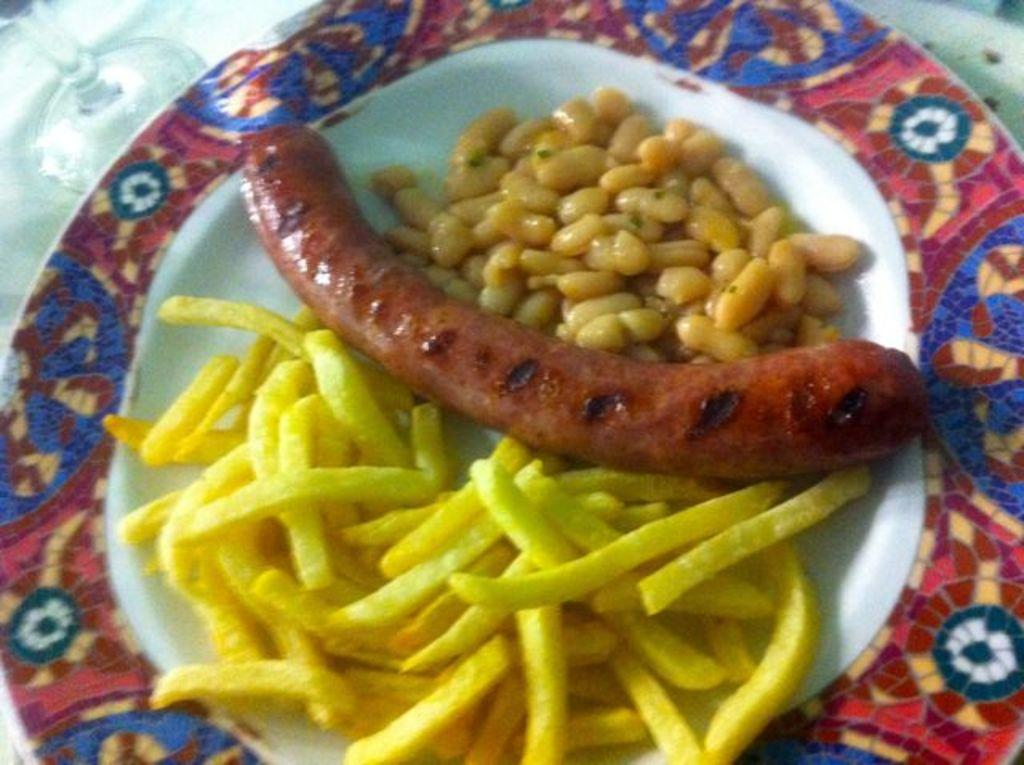What is on the plate in the image? There is a plate with food items in the image. What can be seen beside the plate? There is a glass beside the plate in the image. What type of underwear is visible in the image? There is no underwear present in the image. How is the thumb being used in the image? There is no thumb visible in the image. 